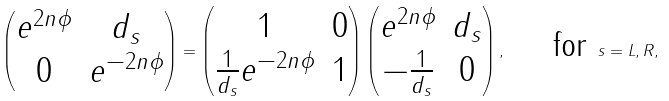Convert formula to latex. <formula><loc_0><loc_0><loc_500><loc_500>\begin{pmatrix} e ^ { 2 n \phi } & d _ { s } \\ 0 & e ^ { - 2 n \phi } \end{pmatrix} = \begin{pmatrix} 1 & 0 \\ \frac { 1 } { d _ { s } } e ^ { - 2 n \phi } & 1 \end{pmatrix} \begin{pmatrix} e ^ { 2 n \phi } & d _ { s } \\ - \frac { 1 } { d _ { s } } & 0 \end{pmatrix} , \quad \text { for } s = L , R ,</formula> 